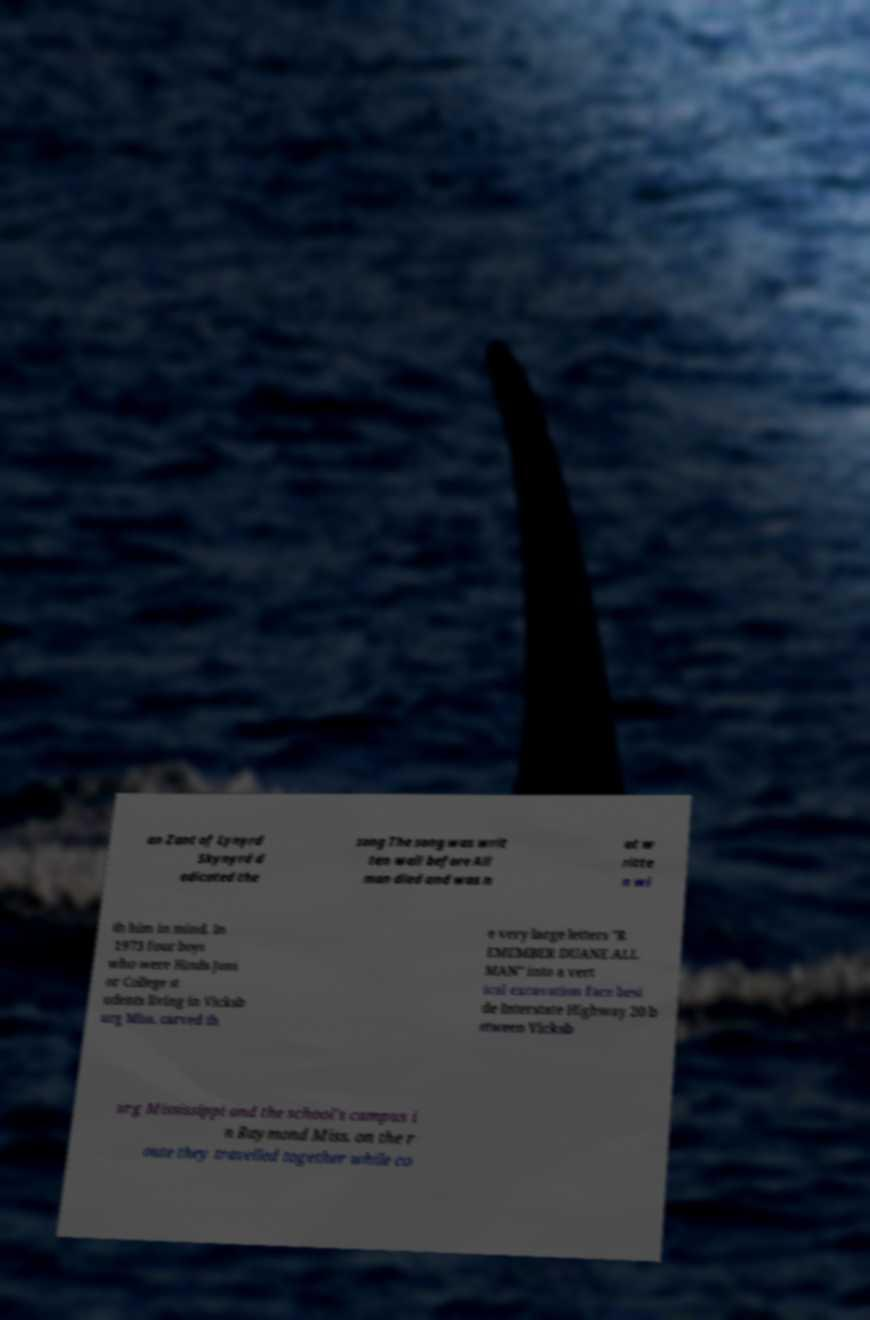Could you assist in decoding the text presented in this image and type it out clearly? an Zant of Lynyrd Skynyrd d edicated the song The song was writ ten well before All man died and was n ot w ritte n wi th him in mind. In 1973 four boys who were Hinds Juni or College st udents living in Vicksb urg Miss. carved th e very large letters "R EMEMBER DUANE ALL MAN" into a vert ical excavation face besi de Interstate Highway 20 b etween Vicksb urg Mississippi and the school's campus i n Raymond Miss. on the r oute they travelled together while co 